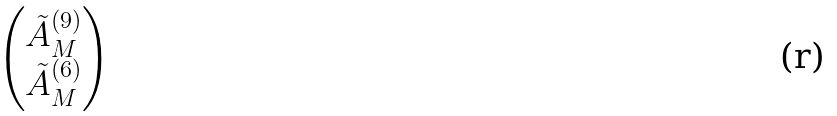<formula> <loc_0><loc_0><loc_500><loc_500>\begin{pmatrix} \tilde { A } _ { M } ^ { ( 9 ) } \\ \tilde { A } _ { M } ^ { ( 6 ) } \end{pmatrix}</formula> 